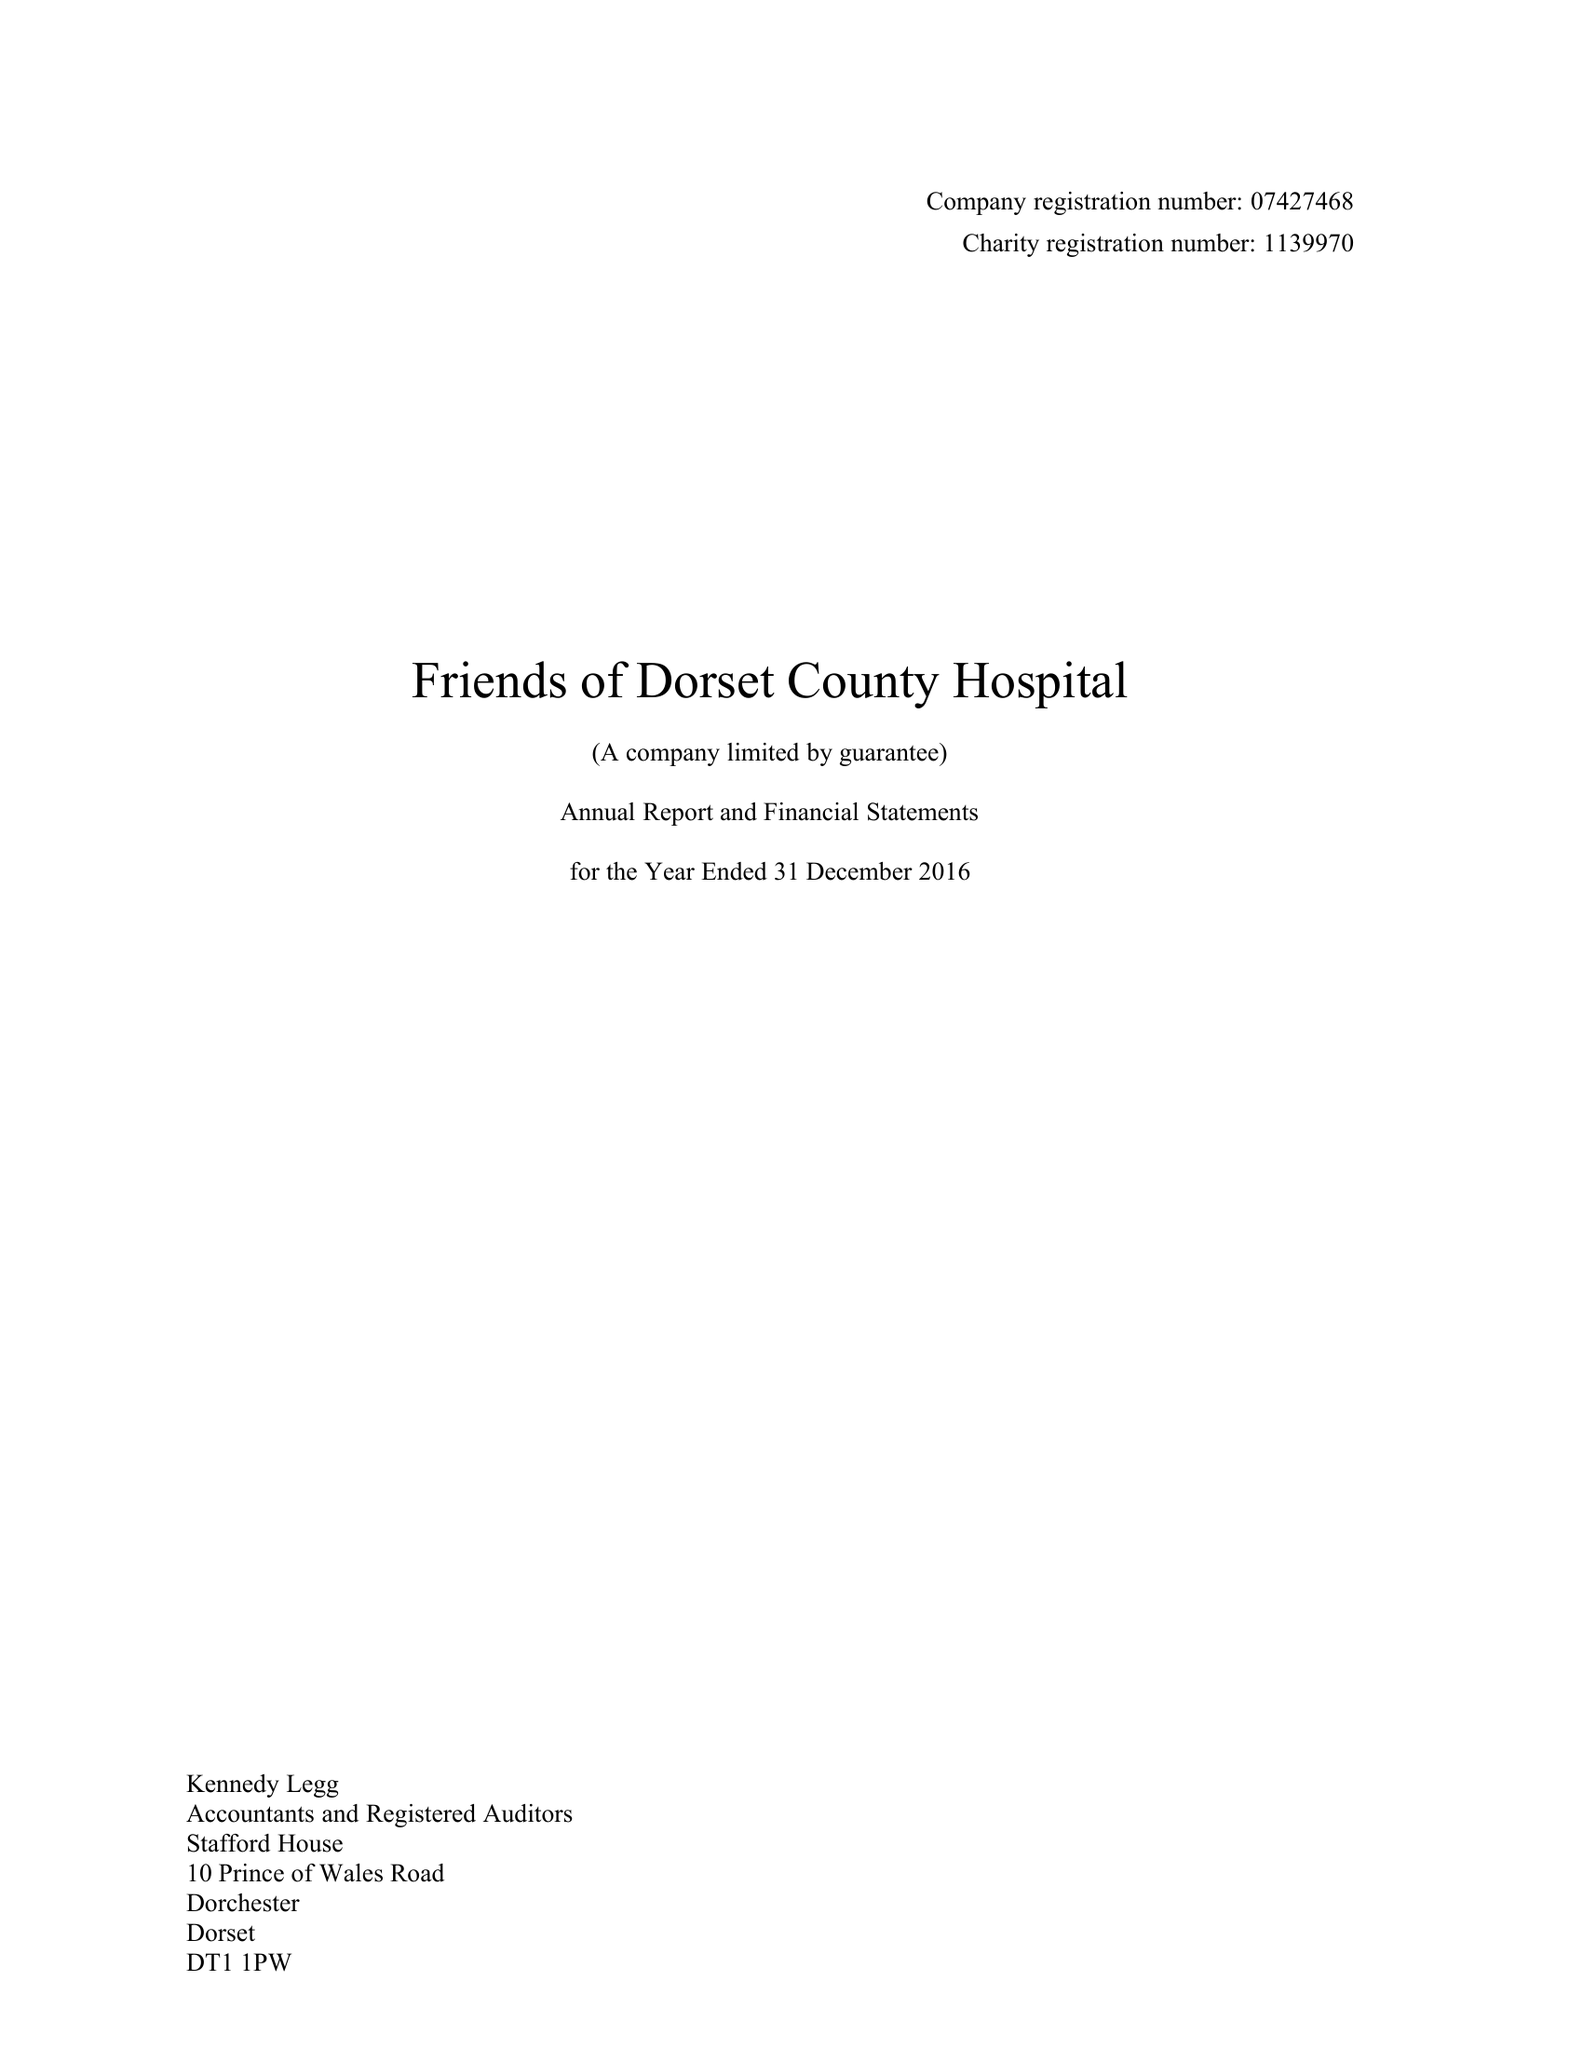What is the value for the report_date?
Answer the question using a single word or phrase. 2016-12-31 